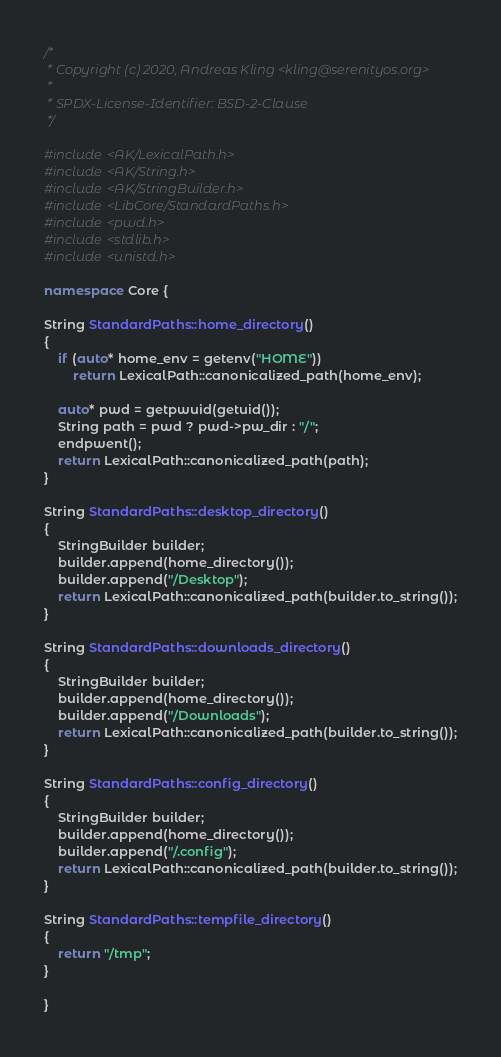Convert code to text. <code><loc_0><loc_0><loc_500><loc_500><_C++_>/*
 * Copyright (c) 2020, Andreas Kling <kling@serenityos.org>
 *
 * SPDX-License-Identifier: BSD-2-Clause
 */

#include <AK/LexicalPath.h>
#include <AK/String.h>
#include <AK/StringBuilder.h>
#include <LibCore/StandardPaths.h>
#include <pwd.h>
#include <stdlib.h>
#include <unistd.h>

namespace Core {

String StandardPaths::home_directory()
{
    if (auto* home_env = getenv("HOME"))
        return LexicalPath::canonicalized_path(home_env);

    auto* pwd = getpwuid(getuid());
    String path = pwd ? pwd->pw_dir : "/";
    endpwent();
    return LexicalPath::canonicalized_path(path);
}

String StandardPaths::desktop_directory()
{
    StringBuilder builder;
    builder.append(home_directory());
    builder.append("/Desktop");
    return LexicalPath::canonicalized_path(builder.to_string());
}

String StandardPaths::downloads_directory()
{
    StringBuilder builder;
    builder.append(home_directory());
    builder.append("/Downloads");
    return LexicalPath::canonicalized_path(builder.to_string());
}

String StandardPaths::config_directory()
{
    StringBuilder builder;
    builder.append(home_directory());
    builder.append("/.config");
    return LexicalPath::canonicalized_path(builder.to_string());
}

String StandardPaths::tempfile_directory()
{
    return "/tmp";
}

}
</code> 